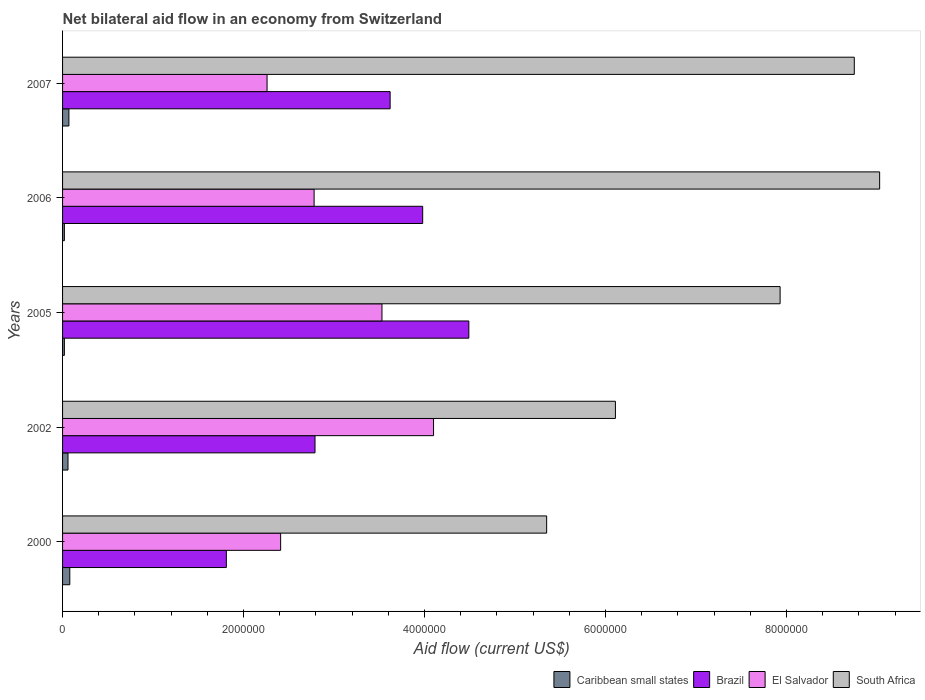Are the number of bars per tick equal to the number of legend labels?
Your answer should be very brief. Yes. How many bars are there on the 1st tick from the top?
Make the answer very short. 4. In how many cases, is the number of bars for a given year not equal to the number of legend labels?
Your response must be concise. 0. What is the net bilateral aid flow in South Africa in 2005?
Your response must be concise. 7.93e+06. Across all years, what is the maximum net bilateral aid flow in El Salvador?
Offer a terse response. 4.10e+06. Across all years, what is the minimum net bilateral aid flow in South Africa?
Your response must be concise. 5.35e+06. In which year was the net bilateral aid flow in El Salvador maximum?
Give a very brief answer. 2002. What is the total net bilateral aid flow in Brazil in the graph?
Your response must be concise. 1.67e+07. What is the difference between the net bilateral aid flow in Brazil in 2000 and that in 2002?
Your response must be concise. -9.80e+05. What is the difference between the net bilateral aid flow in El Salvador in 2005 and the net bilateral aid flow in Brazil in 2000?
Offer a very short reply. 1.72e+06. What is the average net bilateral aid flow in South Africa per year?
Your response must be concise. 7.43e+06. In the year 2002, what is the difference between the net bilateral aid flow in South Africa and net bilateral aid flow in Brazil?
Provide a short and direct response. 3.32e+06. What is the ratio of the net bilateral aid flow in South Africa in 2002 to that in 2006?
Make the answer very short. 0.68. Is the net bilateral aid flow in Caribbean small states in 2000 less than that in 2002?
Your answer should be very brief. No. What is the difference between the highest and the second highest net bilateral aid flow in Brazil?
Keep it short and to the point. 5.10e+05. What is the difference between the highest and the lowest net bilateral aid flow in El Salvador?
Keep it short and to the point. 1.84e+06. Is it the case that in every year, the sum of the net bilateral aid flow in El Salvador and net bilateral aid flow in Brazil is greater than the sum of net bilateral aid flow in South Africa and net bilateral aid flow in Caribbean small states?
Make the answer very short. No. What does the 4th bar from the top in 2005 represents?
Your response must be concise. Caribbean small states. Are the values on the major ticks of X-axis written in scientific E-notation?
Provide a short and direct response. No. Does the graph contain any zero values?
Offer a very short reply. No. Does the graph contain grids?
Provide a short and direct response. No. Where does the legend appear in the graph?
Make the answer very short. Bottom right. How many legend labels are there?
Your answer should be compact. 4. What is the title of the graph?
Your response must be concise. Net bilateral aid flow in an economy from Switzerland. Does "Chad" appear as one of the legend labels in the graph?
Ensure brevity in your answer.  No. What is the Aid flow (current US$) in Caribbean small states in 2000?
Your response must be concise. 8.00e+04. What is the Aid flow (current US$) of Brazil in 2000?
Give a very brief answer. 1.81e+06. What is the Aid flow (current US$) in El Salvador in 2000?
Provide a short and direct response. 2.41e+06. What is the Aid flow (current US$) of South Africa in 2000?
Your response must be concise. 5.35e+06. What is the Aid flow (current US$) of Brazil in 2002?
Give a very brief answer. 2.79e+06. What is the Aid flow (current US$) in El Salvador in 2002?
Your response must be concise. 4.10e+06. What is the Aid flow (current US$) of South Africa in 2002?
Keep it short and to the point. 6.11e+06. What is the Aid flow (current US$) of Brazil in 2005?
Your response must be concise. 4.49e+06. What is the Aid flow (current US$) in El Salvador in 2005?
Ensure brevity in your answer.  3.53e+06. What is the Aid flow (current US$) in South Africa in 2005?
Your answer should be very brief. 7.93e+06. What is the Aid flow (current US$) in Caribbean small states in 2006?
Offer a very short reply. 2.00e+04. What is the Aid flow (current US$) of Brazil in 2006?
Ensure brevity in your answer.  3.98e+06. What is the Aid flow (current US$) of El Salvador in 2006?
Offer a terse response. 2.78e+06. What is the Aid flow (current US$) in South Africa in 2006?
Your answer should be compact. 9.03e+06. What is the Aid flow (current US$) of Caribbean small states in 2007?
Offer a very short reply. 7.00e+04. What is the Aid flow (current US$) in Brazil in 2007?
Offer a very short reply. 3.62e+06. What is the Aid flow (current US$) in El Salvador in 2007?
Your answer should be very brief. 2.26e+06. What is the Aid flow (current US$) in South Africa in 2007?
Provide a succinct answer. 8.75e+06. Across all years, what is the maximum Aid flow (current US$) in Caribbean small states?
Make the answer very short. 8.00e+04. Across all years, what is the maximum Aid flow (current US$) in Brazil?
Provide a succinct answer. 4.49e+06. Across all years, what is the maximum Aid flow (current US$) in El Salvador?
Provide a short and direct response. 4.10e+06. Across all years, what is the maximum Aid flow (current US$) of South Africa?
Your answer should be very brief. 9.03e+06. Across all years, what is the minimum Aid flow (current US$) of Brazil?
Your answer should be compact. 1.81e+06. Across all years, what is the minimum Aid flow (current US$) of El Salvador?
Ensure brevity in your answer.  2.26e+06. Across all years, what is the minimum Aid flow (current US$) of South Africa?
Offer a very short reply. 5.35e+06. What is the total Aid flow (current US$) in Brazil in the graph?
Keep it short and to the point. 1.67e+07. What is the total Aid flow (current US$) of El Salvador in the graph?
Make the answer very short. 1.51e+07. What is the total Aid flow (current US$) of South Africa in the graph?
Offer a very short reply. 3.72e+07. What is the difference between the Aid flow (current US$) in Caribbean small states in 2000 and that in 2002?
Ensure brevity in your answer.  2.00e+04. What is the difference between the Aid flow (current US$) of Brazil in 2000 and that in 2002?
Offer a very short reply. -9.80e+05. What is the difference between the Aid flow (current US$) in El Salvador in 2000 and that in 2002?
Your answer should be very brief. -1.69e+06. What is the difference between the Aid flow (current US$) in South Africa in 2000 and that in 2002?
Provide a succinct answer. -7.60e+05. What is the difference between the Aid flow (current US$) in Caribbean small states in 2000 and that in 2005?
Make the answer very short. 6.00e+04. What is the difference between the Aid flow (current US$) in Brazil in 2000 and that in 2005?
Your answer should be very brief. -2.68e+06. What is the difference between the Aid flow (current US$) in El Salvador in 2000 and that in 2005?
Keep it short and to the point. -1.12e+06. What is the difference between the Aid flow (current US$) of South Africa in 2000 and that in 2005?
Your answer should be very brief. -2.58e+06. What is the difference between the Aid flow (current US$) in Caribbean small states in 2000 and that in 2006?
Offer a very short reply. 6.00e+04. What is the difference between the Aid flow (current US$) of Brazil in 2000 and that in 2006?
Offer a very short reply. -2.17e+06. What is the difference between the Aid flow (current US$) in El Salvador in 2000 and that in 2006?
Give a very brief answer. -3.70e+05. What is the difference between the Aid flow (current US$) of South Africa in 2000 and that in 2006?
Provide a succinct answer. -3.68e+06. What is the difference between the Aid flow (current US$) of Brazil in 2000 and that in 2007?
Keep it short and to the point. -1.81e+06. What is the difference between the Aid flow (current US$) in South Africa in 2000 and that in 2007?
Offer a terse response. -3.40e+06. What is the difference between the Aid flow (current US$) of Brazil in 2002 and that in 2005?
Your answer should be very brief. -1.70e+06. What is the difference between the Aid flow (current US$) of El Salvador in 2002 and that in 2005?
Keep it short and to the point. 5.70e+05. What is the difference between the Aid flow (current US$) of South Africa in 2002 and that in 2005?
Your answer should be very brief. -1.82e+06. What is the difference between the Aid flow (current US$) of Caribbean small states in 2002 and that in 2006?
Provide a short and direct response. 4.00e+04. What is the difference between the Aid flow (current US$) in Brazil in 2002 and that in 2006?
Make the answer very short. -1.19e+06. What is the difference between the Aid flow (current US$) in El Salvador in 2002 and that in 2006?
Offer a terse response. 1.32e+06. What is the difference between the Aid flow (current US$) of South Africa in 2002 and that in 2006?
Ensure brevity in your answer.  -2.92e+06. What is the difference between the Aid flow (current US$) in Caribbean small states in 2002 and that in 2007?
Your answer should be compact. -10000. What is the difference between the Aid flow (current US$) of Brazil in 2002 and that in 2007?
Make the answer very short. -8.30e+05. What is the difference between the Aid flow (current US$) in El Salvador in 2002 and that in 2007?
Provide a short and direct response. 1.84e+06. What is the difference between the Aid flow (current US$) of South Africa in 2002 and that in 2007?
Provide a succinct answer. -2.64e+06. What is the difference between the Aid flow (current US$) in Brazil in 2005 and that in 2006?
Your response must be concise. 5.10e+05. What is the difference between the Aid flow (current US$) in El Salvador in 2005 and that in 2006?
Your answer should be compact. 7.50e+05. What is the difference between the Aid flow (current US$) of South Africa in 2005 and that in 2006?
Provide a short and direct response. -1.10e+06. What is the difference between the Aid flow (current US$) in Caribbean small states in 2005 and that in 2007?
Give a very brief answer. -5.00e+04. What is the difference between the Aid flow (current US$) in Brazil in 2005 and that in 2007?
Provide a succinct answer. 8.70e+05. What is the difference between the Aid flow (current US$) of El Salvador in 2005 and that in 2007?
Make the answer very short. 1.27e+06. What is the difference between the Aid flow (current US$) in South Africa in 2005 and that in 2007?
Your answer should be compact. -8.20e+05. What is the difference between the Aid flow (current US$) of Caribbean small states in 2006 and that in 2007?
Your answer should be compact. -5.00e+04. What is the difference between the Aid flow (current US$) in Brazil in 2006 and that in 2007?
Ensure brevity in your answer.  3.60e+05. What is the difference between the Aid flow (current US$) of El Salvador in 2006 and that in 2007?
Your response must be concise. 5.20e+05. What is the difference between the Aid flow (current US$) in South Africa in 2006 and that in 2007?
Offer a very short reply. 2.80e+05. What is the difference between the Aid flow (current US$) in Caribbean small states in 2000 and the Aid flow (current US$) in Brazil in 2002?
Keep it short and to the point. -2.71e+06. What is the difference between the Aid flow (current US$) of Caribbean small states in 2000 and the Aid flow (current US$) of El Salvador in 2002?
Keep it short and to the point. -4.02e+06. What is the difference between the Aid flow (current US$) of Caribbean small states in 2000 and the Aid flow (current US$) of South Africa in 2002?
Your answer should be compact. -6.03e+06. What is the difference between the Aid flow (current US$) in Brazil in 2000 and the Aid flow (current US$) in El Salvador in 2002?
Provide a short and direct response. -2.29e+06. What is the difference between the Aid flow (current US$) of Brazil in 2000 and the Aid flow (current US$) of South Africa in 2002?
Your answer should be compact. -4.30e+06. What is the difference between the Aid flow (current US$) of El Salvador in 2000 and the Aid flow (current US$) of South Africa in 2002?
Ensure brevity in your answer.  -3.70e+06. What is the difference between the Aid flow (current US$) in Caribbean small states in 2000 and the Aid flow (current US$) in Brazil in 2005?
Offer a terse response. -4.41e+06. What is the difference between the Aid flow (current US$) in Caribbean small states in 2000 and the Aid flow (current US$) in El Salvador in 2005?
Provide a short and direct response. -3.45e+06. What is the difference between the Aid flow (current US$) of Caribbean small states in 2000 and the Aid flow (current US$) of South Africa in 2005?
Keep it short and to the point. -7.85e+06. What is the difference between the Aid flow (current US$) of Brazil in 2000 and the Aid flow (current US$) of El Salvador in 2005?
Offer a terse response. -1.72e+06. What is the difference between the Aid flow (current US$) in Brazil in 2000 and the Aid flow (current US$) in South Africa in 2005?
Offer a very short reply. -6.12e+06. What is the difference between the Aid flow (current US$) of El Salvador in 2000 and the Aid flow (current US$) of South Africa in 2005?
Offer a very short reply. -5.52e+06. What is the difference between the Aid flow (current US$) in Caribbean small states in 2000 and the Aid flow (current US$) in Brazil in 2006?
Ensure brevity in your answer.  -3.90e+06. What is the difference between the Aid flow (current US$) of Caribbean small states in 2000 and the Aid flow (current US$) of El Salvador in 2006?
Offer a terse response. -2.70e+06. What is the difference between the Aid flow (current US$) of Caribbean small states in 2000 and the Aid flow (current US$) of South Africa in 2006?
Provide a short and direct response. -8.95e+06. What is the difference between the Aid flow (current US$) in Brazil in 2000 and the Aid flow (current US$) in El Salvador in 2006?
Provide a short and direct response. -9.70e+05. What is the difference between the Aid flow (current US$) of Brazil in 2000 and the Aid flow (current US$) of South Africa in 2006?
Your answer should be very brief. -7.22e+06. What is the difference between the Aid flow (current US$) in El Salvador in 2000 and the Aid flow (current US$) in South Africa in 2006?
Offer a very short reply. -6.62e+06. What is the difference between the Aid flow (current US$) of Caribbean small states in 2000 and the Aid flow (current US$) of Brazil in 2007?
Ensure brevity in your answer.  -3.54e+06. What is the difference between the Aid flow (current US$) in Caribbean small states in 2000 and the Aid flow (current US$) in El Salvador in 2007?
Your answer should be compact. -2.18e+06. What is the difference between the Aid flow (current US$) in Caribbean small states in 2000 and the Aid flow (current US$) in South Africa in 2007?
Your answer should be very brief. -8.67e+06. What is the difference between the Aid flow (current US$) of Brazil in 2000 and the Aid flow (current US$) of El Salvador in 2007?
Ensure brevity in your answer.  -4.50e+05. What is the difference between the Aid flow (current US$) in Brazil in 2000 and the Aid flow (current US$) in South Africa in 2007?
Offer a terse response. -6.94e+06. What is the difference between the Aid flow (current US$) of El Salvador in 2000 and the Aid flow (current US$) of South Africa in 2007?
Your response must be concise. -6.34e+06. What is the difference between the Aid flow (current US$) of Caribbean small states in 2002 and the Aid flow (current US$) of Brazil in 2005?
Give a very brief answer. -4.43e+06. What is the difference between the Aid flow (current US$) of Caribbean small states in 2002 and the Aid flow (current US$) of El Salvador in 2005?
Provide a short and direct response. -3.47e+06. What is the difference between the Aid flow (current US$) of Caribbean small states in 2002 and the Aid flow (current US$) of South Africa in 2005?
Make the answer very short. -7.87e+06. What is the difference between the Aid flow (current US$) of Brazil in 2002 and the Aid flow (current US$) of El Salvador in 2005?
Your response must be concise. -7.40e+05. What is the difference between the Aid flow (current US$) in Brazil in 2002 and the Aid flow (current US$) in South Africa in 2005?
Provide a short and direct response. -5.14e+06. What is the difference between the Aid flow (current US$) in El Salvador in 2002 and the Aid flow (current US$) in South Africa in 2005?
Make the answer very short. -3.83e+06. What is the difference between the Aid flow (current US$) in Caribbean small states in 2002 and the Aid flow (current US$) in Brazil in 2006?
Make the answer very short. -3.92e+06. What is the difference between the Aid flow (current US$) of Caribbean small states in 2002 and the Aid flow (current US$) of El Salvador in 2006?
Provide a succinct answer. -2.72e+06. What is the difference between the Aid flow (current US$) in Caribbean small states in 2002 and the Aid flow (current US$) in South Africa in 2006?
Offer a terse response. -8.97e+06. What is the difference between the Aid flow (current US$) of Brazil in 2002 and the Aid flow (current US$) of South Africa in 2006?
Provide a succinct answer. -6.24e+06. What is the difference between the Aid flow (current US$) of El Salvador in 2002 and the Aid flow (current US$) of South Africa in 2006?
Your response must be concise. -4.93e+06. What is the difference between the Aid flow (current US$) of Caribbean small states in 2002 and the Aid flow (current US$) of Brazil in 2007?
Your response must be concise. -3.56e+06. What is the difference between the Aid flow (current US$) of Caribbean small states in 2002 and the Aid flow (current US$) of El Salvador in 2007?
Provide a succinct answer. -2.20e+06. What is the difference between the Aid flow (current US$) in Caribbean small states in 2002 and the Aid flow (current US$) in South Africa in 2007?
Your answer should be compact. -8.69e+06. What is the difference between the Aid flow (current US$) in Brazil in 2002 and the Aid flow (current US$) in El Salvador in 2007?
Your answer should be very brief. 5.30e+05. What is the difference between the Aid flow (current US$) of Brazil in 2002 and the Aid flow (current US$) of South Africa in 2007?
Provide a succinct answer. -5.96e+06. What is the difference between the Aid flow (current US$) of El Salvador in 2002 and the Aid flow (current US$) of South Africa in 2007?
Offer a very short reply. -4.65e+06. What is the difference between the Aid flow (current US$) of Caribbean small states in 2005 and the Aid flow (current US$) of Brazil in 2006?
Provide a short and direct response. -3.96e+06. What is the difference between the Aid flow (current US$) of Caribbean small states in 2005 and the Aid flow (current US$) of El Salvador in 2006?
Ensure brevity in your answer.  -2.76e+06. What is the difference between the Aid flow (current US$) in Caribbean small states in 2005 and the Aid flow (current US$) in South Africa in 2006?
Give a very brief answer. -9.01e+06. What is the difference between the Aid flow (current US$) of Brazil in 2005 and the Aid flow (current US$) of El Salvador in 2006?
Make the answer very short. 1.71e+06. What is the difference between the Aid flow (current US$) of Brazil in 2005 and the Aid flow (current US$) of South Africa in 2006?
Ensure brevity in your answer.  -4.54e+06. What is the difference between the Aid flow (current US$) in El Salvador in 2005 and the Aid flow (current US$) in South Africa in 2006?
Keep it short and to the point. -5.50e+06. What is the difference between the Aid flow (current US$) in Caribbean small states in 2005 and the Aid flow (current US$) in Brazil in 2007?
Provide a short and direct response. -3.60e+06. What is the difference between the Aid flow (current US$) of Caribbean small states in 2005 and the Aid flow (current US$) of El Salvador in 2007?
Your response must be concise. -2.24e+06. What is the difference between the Aid flow (current US$) in Caribbean small states in 2005 and the Aid flow (current US$) in South Africa in 2007?
Make the answer very short. -8.73e+06. What is the difference between the Aid flow (current US$) in Brazil in 2005 and the Aid flow (current US$) in El Salvador in 2007?
Provide a succinct answer. 2.23e+06. What is the difference between the Aid flow (current US$) in Brazil in 2005 and the Aid flow (current US$) in South Africa in 2007?
Your answer should be very brief. -4.26e+06. What is the difference between the Aid flow (current US$) in El Salvador in 2005 and the Aid flow (current US$) in South Africa in 2007?
Your response must be concise. -5.22e+06. What is the difference between the Aid flow (current US$) of Caribbean small states in 2006 and the Aid flow (current US$) of Brazil in 2007?
Your response must be concise. -3.60e+06. What is the difference between the Aid flow (current US$) of Caribbean small states in 2006 and the Aid flow (current US$) of El Salvador in 2007?
Your answer should be compact. -2.24e+06. What is the difference between the Aid flow (current US$) in Caribbean small states in 2006 and the Aid flow (current US$) in South Africa in 2007?
Ensure brevity in your answer.  -8.73e+06. What is the difference between the Aid flow (current US$) in Brazil in 2006 and the Aid flow (current US$) in El Salvador in 2007?
Your answer should be compact. 1.72e+06. What is the difference between the Aid flow (current US$) of Brazil in 2006 and the Aid flow (current US$) of South Africa in 2007?
Keep it short and to the point. -4.77e+06. What is the difference between the Aid flow (current US$) in El Salvador in 2006 and the Aid flow (current US$) in South Africa in 2007?
Keep it short and to the point. -5.97e+06. What is the average Aid flow (current US$) of Caribbean small states per year?
Ensure brevity in your answer.  5.00e+04. What is the average Aid flow (current US$) of Brazil per year?
Make the answer very short. 3.34e+06. What is the average Aid flow (current US$) in El Salvador per year?
Make the answer very short. 3.02e+06. What is the average Aid flow (current US$) in South Africa per year?
Offer a terse response. 7.43e+06. In the year 2000, what is the difference between the Aid flow (current US$) in Caribbean small states and Aid flow (current US$) in Brazil?
Ensure brevity in your answer.  -1.73e+06. In the year 2000, what is the difference between the Aid flow (current US$) in Caribbean small states and Aid flow (current US$) in El Salvador?
Provide a succinct answer. -2.33e+06. In the year 2000, what is the difference between the Aid flow (current US$) in Caribbean small states and Aid flow (current US$) in South Africa?
Give a very brief answer. -5.27e+06. In the year 2000, what is the difference between the Aid flow (current US$) of Brazil and Aid flow (current US$) of El Salvador?
Keep it short and to the point. -6.00e+05. In the year 2000, what is the difference between the Aid flow (current US$) in Brazil and Aid flow (current US$) in South Africa?
Your answer should be very brief. -3.54e+06. In the year 2000, what is the difference between the Aid flow (current US$) in El Salvador and Aid flow (current US$) in South Africa?
Your response must be concise. -2.94e+06. In the year 2002, what is the difference between the Aid flow (current US$) of Caribbean small states and Aid flow (current US$) of Brazil?
Provide a succinct answer. -2.73e+06. In the year 2002, what is the difference between the Aid flow (current US$) of Caribbean small states and Aid flow (current US$) of El Salvador?
Your answer should be compact. -4.04e+06. In the year 2002, what is the difference between the Aid flow (current US$) in Caribbean small states and Aid flow (current US$) in South Africa?
Your answer should be compact. -6.05e+06. In the year 2002, what is the difference between the Aid flow (current US$) in Brazil and Aid flow (current US$) in El Salvador?
Offer a terse response. -1.31e+06. In the year 2002, what is the difference between the Aid flow (current US$) of Brazil and Aid flow (current US$) of South Africa?
Ensure brevity in your answer.  -3.32e+06. In the year 2002, what is the difference between the Aid flow (current US$) in El Salvador and Aid flow (current US$) in South Africa?
Provide a succinct answer. -2.01e+06. In the year 2005, what is the difference between the Aid flow (current US$) of Caribbean small states and Aid flow (current US$) of Brazil?
Give a very brief answer. -4.47e+06. In the year 2005, what is the difference between the Aid flow (current US$) in Caribbean small states and Aid flow (current US$) in El Salvador?
Provide a succinct answer. -3.51e+06. In the year 2005, what is the difference between the Aid flow (current US$) of Caribbean small states and Aid flow (current US$) of South Africa?
Provide a succinct answer. -7.91e+06. In the year 2005, what is the difference between the Aid flow (current US$) in Brazil and Aid flow (current US$) in El Salvador?
Provide a succinct answer. 9.60e+05. In the year 2005, what is the difference between the Aid flow (current US$) of Brazil and Aid flow (current US$) of South Africa?
Keep it short and to the point. -3.44e+06. In the year 2005, what is the difference between the Aid flow (current US$) of El Salvador and Aid flow (current US$) of South Africa?
Offer a very short reply. -4.40e+06. In the year 2006, what is the difference between the Aid flow (current US$) in Caribbean small states and Aid flow (current US$) in Brazil?
Offer a terse response. -3.96e+06. In the year 2006, what is the difference between the Aid flow (current US$) of Caribbean small states and Aid flow (current US$) of El Salvador?
Your response must be concise. -2.76e+06. In the year 2006, what is the difference between the Aid flow (current US$) of Caribbean small states and Aid flow (current US$) of South Africa?
Give a very brief answer. -9.01e+06. In the year 2006, what is the difference between the Aid flow (current US$) in Brazil and Aid flow (current US$) in El Salvador?
Offer a very short reply. 1.20e+06. In the year 2006, what is the difference between the Aid flow (current US$) of Brazil and Aid flow (current US$) of South Africa?
Give a very brief answer. -5.05e+06. In the year 2006, what is the difference between the Aid flow (current US$) of El Salvador and Aid flow (current US$) of South Africa?
Offer a terse response. -6.25e+06. In the year 2007, what is the difference between the Aid flow (current US$) in Caribbean small states and Aid flow (current US$) in Brazil?
Offer a very short reply. -3.55e+06. In the year 2007, what is the difference between the Aid flow (current US$) in Caribbean small states and Aid flow (current US$) in El Salvador?
Give a very brief answer. -2.19e+06. In the year 2007, what is the difference between the Aid flow (current US$) in Caribbean small states and Aid flow (current US$) in South Africa?
Keep it short and to the point. -8.68e+06. In the year 2007, what is the difference between the Aid flow (current US$) in Brazil and Aid flow (current US$) in El Salvador?
Your response must be concise. 1.36e+06. In the year 2007, what is the difference between the Aid flow (current US$) in Brazil and Aid flow (current US$) in South Africa?
Ensure brevity in your answer.  -5.13e+06. In the year 2007, what is the difference between the Aid flow (current US$) in El Salvador and Aid flow (current US$) in South Africa?
Keep it short and to the point. -6.49e+06. What is the ratio of the Aid flow (current US$) of Brazil in 2000 to that in 2002?
Your answer should be compact. 0.65. What is the ratio of the Aid flow (current US$) in El Salvador in 2000 to that in 2002?
Ensure brevity in your answer.  0.59. What is the ratio of the Aid flow (current US$) in South Africa in 2000 to that in 2002?
Offer a very short reply. 0.88. What is the ratio of the Aid flow (current US$) in Brazil in 2000 to that in 2005?
Make the answer very short. 0.4. What is the ratio of the Aid flow (current US$) of El Salvador in 2000 to that in 2005?
Make the answer very short. 0.68. What is the ratio of the Aid flow (current US$) of South Africa in 2000 to that in 2005?
Your answer should be very brief. 0.67. What is the ratio of the Aid flow (current US$) of Caribbean small states in 2000 to that in 2006?
Make the answer very short. 4. What is the ratio of the Aid flow (current US$) of Brazil in 2000 to that in 2006?
Give a very brief answer. 0.45. What is the ratio of the Aid flow (current US$) of El Salvador in 2000 to that in 2006?
Give a very brief answer. 0.87. What is the ratio of the Aid flow (current US$) in South Africa in 2000 to that in 2006?
Provide a succinct answer. 0.59. What is the ratio of the Aid flow (current US$) of Caribbean small states in 2000 to that in 2007?
Your answer should be compact. 1.14. What is the ratio of the Aid flow (current US$) of Brazil in 2000 to that in 2007?
Make the answer very short. 0.5. What is the ratio of the Aid flow (current US$) in El Salvador in 2000 to that in 2007?
Offer a terse response. 1.07. What is the ratio of the Aid flow (current US$) of South Africa in 2000 to that in 2007?
Give a very brief answer. 0.61. What is the ratio of the Aid flow (current US$) of Brazil in 2002 to that in 2005?
Your answer should be compact. 0.62. What is the ratio of the Aid flow (current US$) of El Salvador in 2002 to that in 2005?
Your answer should be compact. 1.16. What is the ratio of the Aid flow (current US$) in South Africa in 2002 to that in 2005?
Your answer should be compact. 0.77. What is the ratio of the Aid flow (current US$) in Brazil in 2002 to that in 2006?
Provide a succinct answer. 0.7. What is the ratio of the Aid flow (current US$) in El Salvador in 2002 to that in 2006?
Give a very brief answer. 1.47. What is the ratio of the Aid flow (current US$) of South Africa in 2002 to that in 2006?
Your answer should be compact. 0.68. What is the ratio of the Aid flow (current US$) of Brazil in 2002 to that in 2007?
Ensure brevity in your answer.  0.77. What is the ratio of the Aid flow (current US$) in El Salvador in 2002 to that in 2007?
Your answer should be very brief. 1.81. What is the ratio of the Aid flow (current US$) of South Africa in 2002 to that in 2007?
Ensure brevity in your answer.  0.7. What is the ratio of the Aid flow (current US$) of Caribbean small states in 2005 to that in 2006?
Your answer should be compact. 1. What is the ratio of the Aid flow (current US$) of Brazil in 2005 to that in 2006?
Provide a succinct answer. 1.13. What is the ratio of the Aid flow (current US$) in El Salvador in 2005 to that in 2006?
Offer a terse response. 1.27. What is the ratio of the Aid flow (current US$) of South Africa in 2005 to that in 2006?
Provide a short and direct response. 0.88. What is the ratio of the Aid flow (current US$) in Caribbean small states in 2005 to that in 2007?
Your answer should be compact. 0.29. What is the ratio of the Aid flow (current US$) of Brazil in 2005 to that in 2007?
Your response must be concise. 1.24. What is the ratio of the Aid flow (current US$) of El Salvador in 2005 to that in 2007?
Your answer should be very brief. 1.56. What is the ratio of the Aid flow (current US$) of South Africa in 2005 to that in 2007?
Keep it short and to the point. 0.91. What is the ratio of the Aid flow (current US$) in Caribbean small states in 2006 to that in 2007?
Provide a short and direct response. 0.29. What is the ratio of the Aid flow (current US$) of Brazil in 2006 to that in 2007?
Ensure brevity in your answer.  1.1. What is the ratio of the Aid flow (current US$) of El Salvador in 2006 to that in 2007?
Keep it short and to the point. 1.23. What is the ratio of the Aid flow (current US$) of South Africa in 2006 to that in 2007?
Keep it short and to the point. 1.03. What is the difference between the highest and the second highest Aid flow (current US$) of Brazil?
Keep it short and to the point. 5.10e+05. What is the difference between the highest and the second highest Aid flow (current US$) in El Salvador?
Provide a succinct answer. 5.70e+05. What is the difference between the highest and the second highest Aid flow (current US$) of South Africa?
Your response must be concise. 2.80e+05. What is the difference between the highest and the lowest Aid flow (current US$) of Caribbean small states?
Ensure brevity in your answer.  6.00e+04. What is the difference between the highest and the lowest Aid flow (current US$) in Brazil?
Keep it short and to the point. 2.68e+06. What is the difference between the highest and the lowest Aid flow (current US$) of El Salvador?
Make the answer very short. 1.84e+06. What is the difference between the highest and the lowest Aid flow (current US$) of South Africa?
Provide a succinct answer. 3.68e+06. 